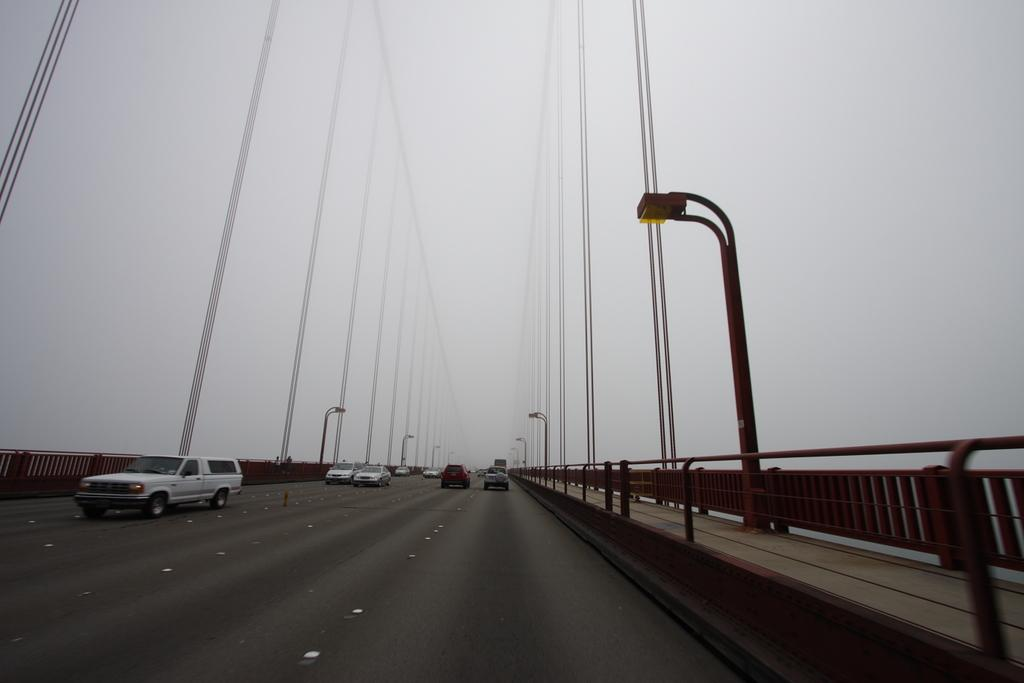What can be seen on the road in the image? There are vehicles on the road in the image. What structures are present along the road? Light poles are visible in the image. What type of barrier is present in the image? There is a fence in the image. Where is the bucket located in the image? There is no bucket present in the image. Can you hear anyone crying in the image? The image is silent, and there is no indication of anyone crying. 